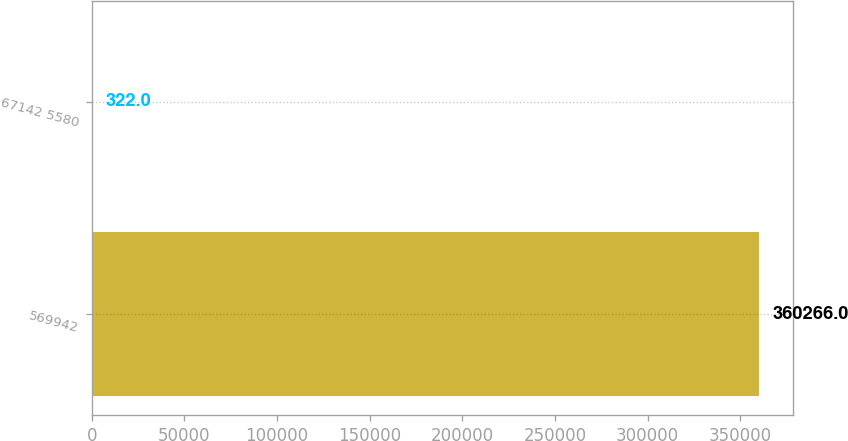Convert chart to OTSL. <chart><loc_0><loc_0><loc_500><loc_500><bar_chart><fcel>569942<fcel>67142 5580<nl><fcel>360266<fcel>322<nl></chart> 